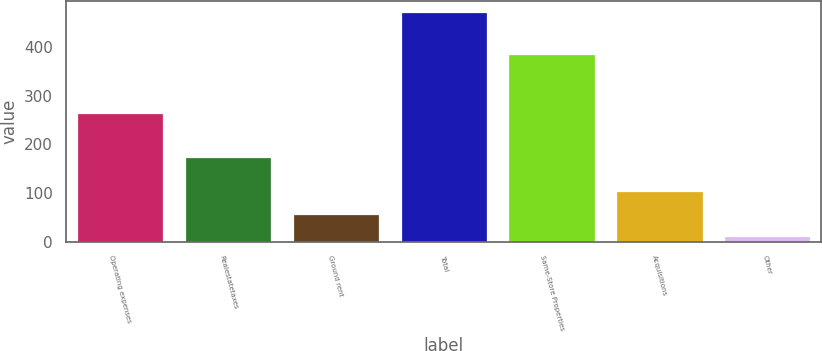Convert chart to OTSL. <chart><loc_0><loc_0><loc_500><loc_500><bar_chart><fcel>Operating expenses<fcel>Realestatetaxes<fcel>Ground rent<fcel>Total<fcel>Same-Store Properties<fcel>Acquisitions<fcel>Other<nl><fcel>263.7<fcel>174.5<fcel>57.19<fcel>471.1<fcel>385.9<fcel>103.18<fcel>11.2<nl></chart> 